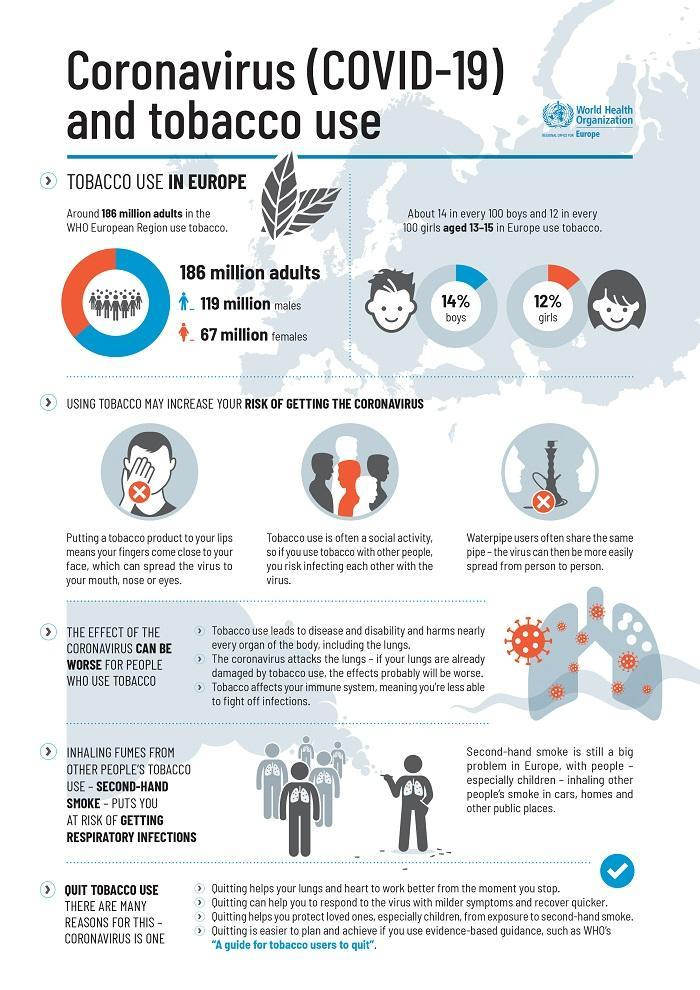What male population in Europe indulge in tobacco usage according to the WHO?
Answer the question with a short phrase. 119 million What percent of boys aged 13-15 use tobacco in Europe according to the WHO? 14% What female population in Europe indulge in tobacco usage according to the WHO? 67 million What percent of girls aged 13-15 use tobacco in Europe according to the WHO? 12% 